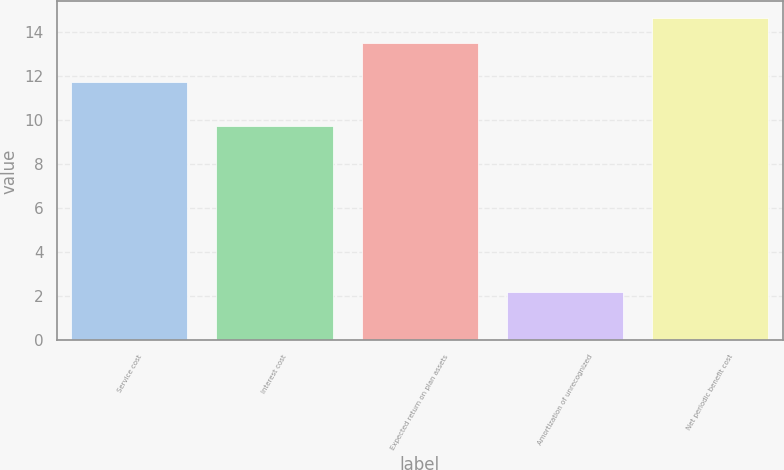Convert chart to OTSL. <chart><loc_0><loc_0><loc_500><loc_500><bar_chart><fcel>Service cost<fcel>Interest cost<fcel>Expected return on plan assets<fcel>Amortization of unrecognized<fcel>Net periodic benefit cost<nl><fcel>11.7<fcel>9.7<fcel>13.5<fcel>2.2<fcel>14.64<nl></chart> 